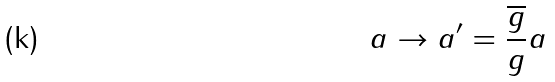<formula> <loc_0><loc_0><loc_500><loc_500>a \rightarrow a ^ { \prime } = \frac { \overline { g } } { g } a</formula> 